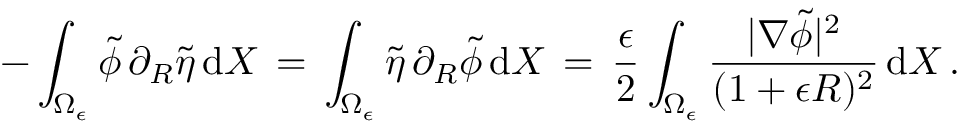<formula> <loc_0><loc_0><loc_500><loc_500>- \int _ { \Omega _ { \epsilon } } \tilde { \phi } \, \partial _ { R } \tilde { \eta } \, d X \, = \, \int _ { \Omega _ { \epsilon } } \tilde { \eta } \, \partial _ { R } \tilde { \phi } \, d X \, = \, \frac { \epsilon } { 2 } \int _ { \Omega _ { \epsilon } } \frac { | \nabla \tilde { \phi } | ^ { 2 } } { ( 1 + \epsilon R ) ^ { 2 } } \, d X \, .</formula> 